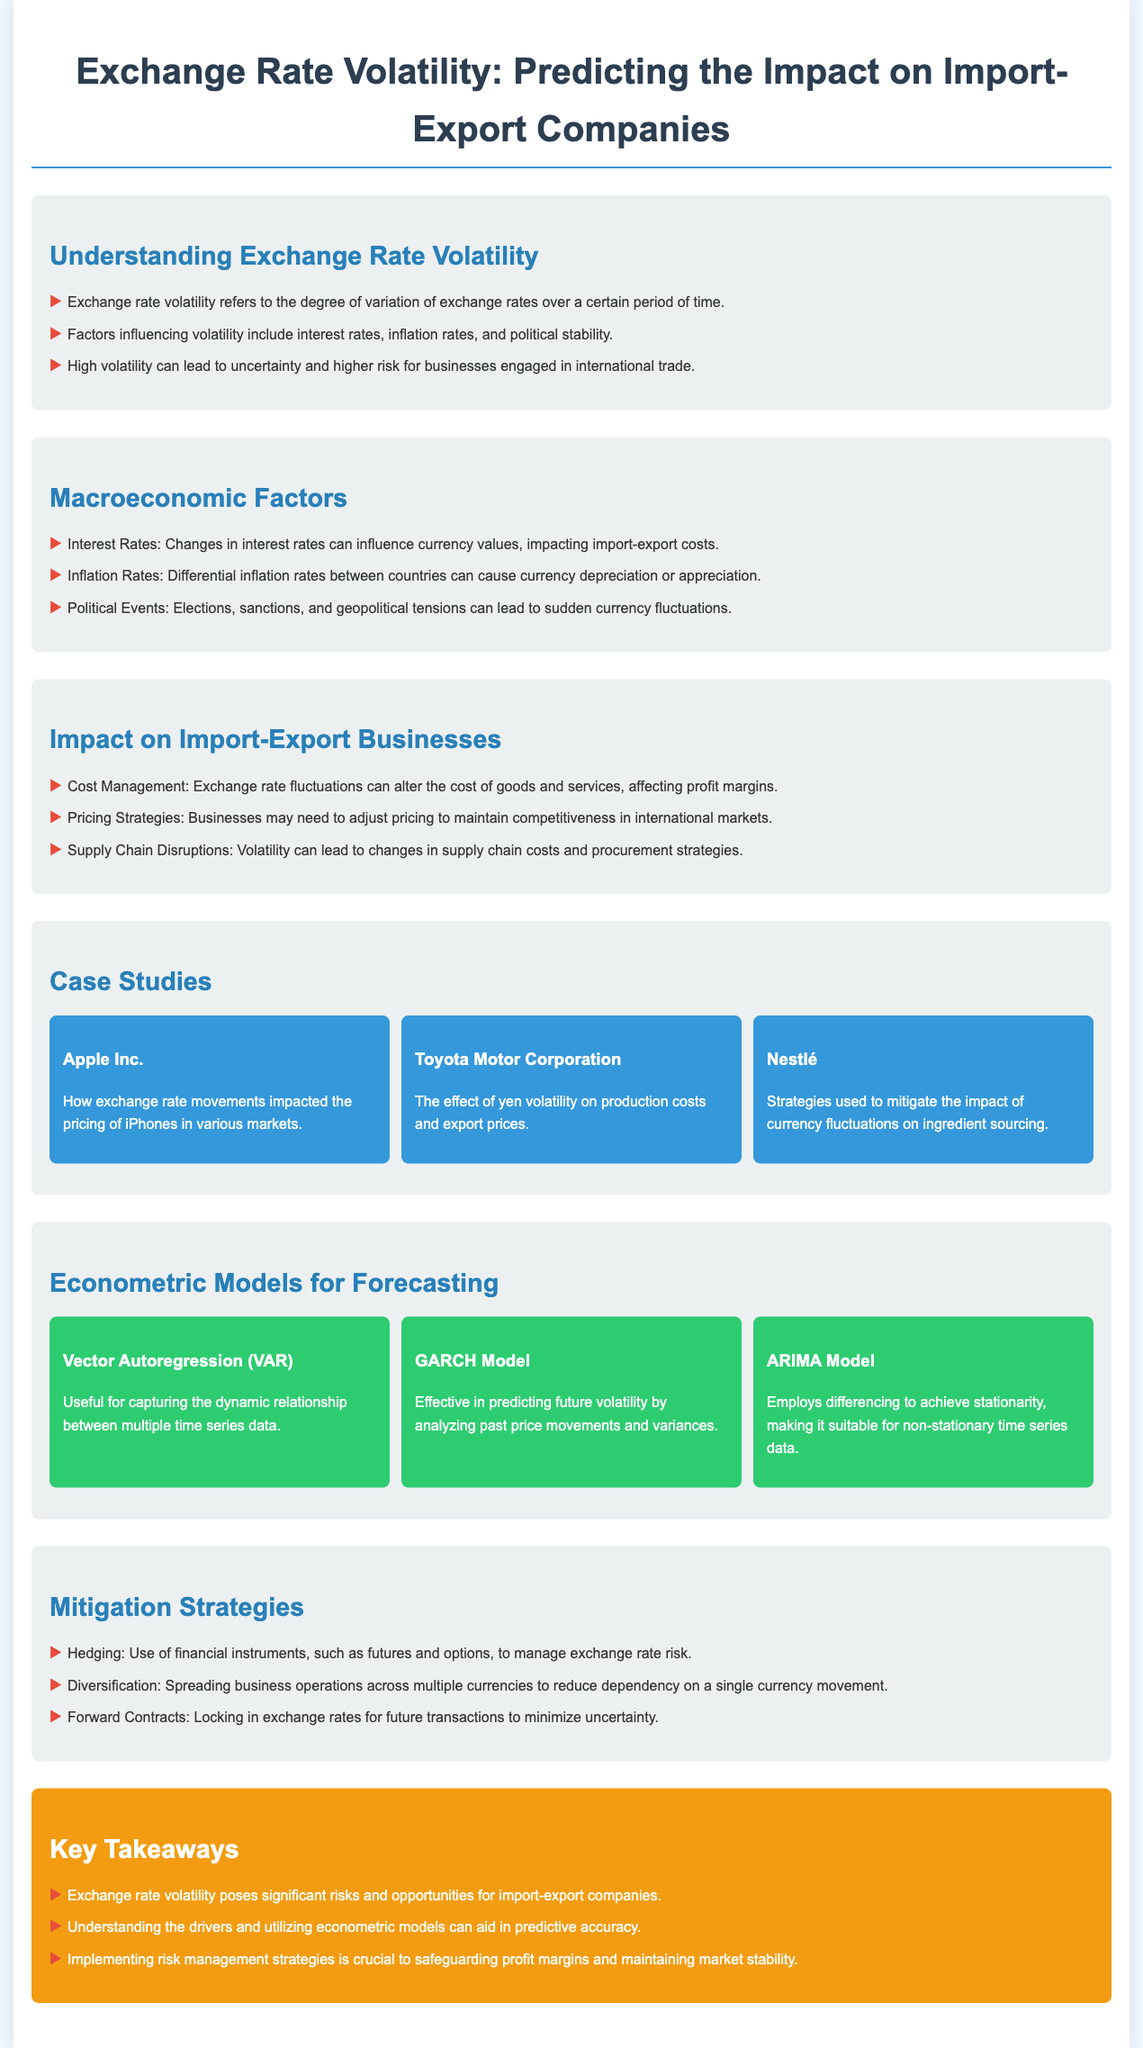What is exchange rate volatility? Exchange rate volatility refers to the degree of variation of exchange rates over a certain period of time.
Answer: Degree of variation Which macroeconomic factor can cause currency depreciation? Differential inflation rates between countries can cause currency depreciation or appreciation.
Answer: Inflation Rates Name a case study mentioned in the document. The document provides several case studies including Apple Inc., Toyota Motor Corporation, and Nestlé.
Answer: Apple Inc What model is effective in predicting future volatility? The GARCH Model is effective in predicting future volatility by analyzing past price movements and variances.
Answer: GARCH Model What strategy involves the use of financial instruments to manage exchange rate risk? The strategy that involves the use of financial instruments to manage exchange rate risk is Hedging.
Answer: Hedging How many econometric models are mentioned in the document? The document lists three econometric models: VAR, GARCH, and ARIMA.
Answer: Three What is one way businesses might adjust to exchange rate fluctuations? Businesses may need to adjust pricing to maintain competitiveness in international markets.
Answer: Adjust pricing What color is used for the key takeaways section? The key takeaways section has a background color of f39c12.
Answer: f39c12 What should import-export companies implement to safeguard profit margins? Implementing risk management strategies is crucial to safeguarding profit margins and maintaining market stability.
Answer: Risk management strategies 